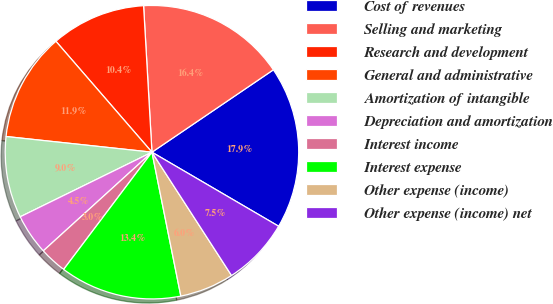Convert chart. <chart><loc_0><loc_0><loc_500><loc_500><pie_chart><fcel>Cost of revenues<fcel>Selling and marketing<fcel>Research and development<fcel>General and administrative<fcel>Amortization of intangible<fcel>Depreciation and amortization<fcel>Interest income<fcel>Interest expense<fcel>Other expense (income)<fcel>Other expense (income) net<nl><fcel>17.91%<fcel>16.42%<fcel>10.45%<fcel>11.94%<fcel>8.96%<fcel>4.48%<fcel>2.99%<fcel>13.43%<fcel>5.97%<fcel>7.46%<nl></chart> 